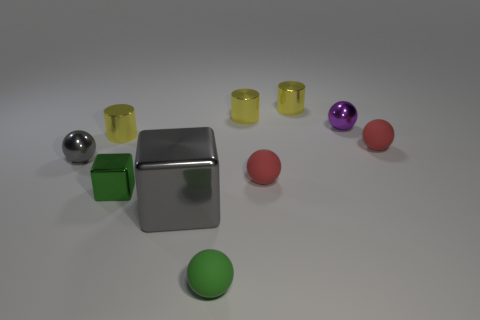Subtract all yellow cylinders. How many were subtracted if there are2yellow cylinders left? 1 Subtract 2 balls. How many balls are left? 3 Subtract all yellow balls. Subtract all red cubes. How many balls are left? 5 Subtract all blocks. How many objects are left? 8 Subtract all brown cylinders. Subtract all big blocks. How many objects are left? 9 Add 1 green objects. How many green objects are left? 3 Add 6 small green things. How many small green things exist? 8 Subtract 0 blue cubes. How many objects are left? 10 